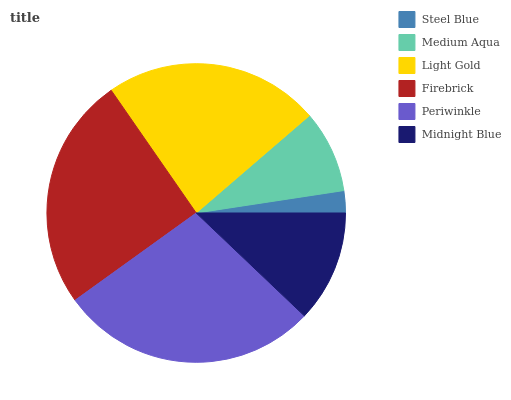Is Steel Blue the minimum?
Answer yes or no. Yes. Is Periwinkle the maximum?
Answer yes or no. Yes. Is Medium Aqua the minimum?
Answer yes or no. No. Is Medium Aqua the maximum?
Answer yes or no. No. Is Medium Aqua greater than Steel Blue?
Answer yes or no. Yes. Is Steel Blue less than Medium Aqua?
Answer yes or no. Yes. Is Steel Blue greater than Medium Aqua?
Answer yes or no. No. Is Medium Aqua less than Steel Blue?
Answer yes or no. No. Is Light Gold the high median?
Answer yes or no. Yes. Is Midnight Blue the low median?
Answer yes or no. Yes. Is Medium Aqua the high median?
Answer yes or no. No. Is Firebrick the low median?
Answer yes or no. No. 